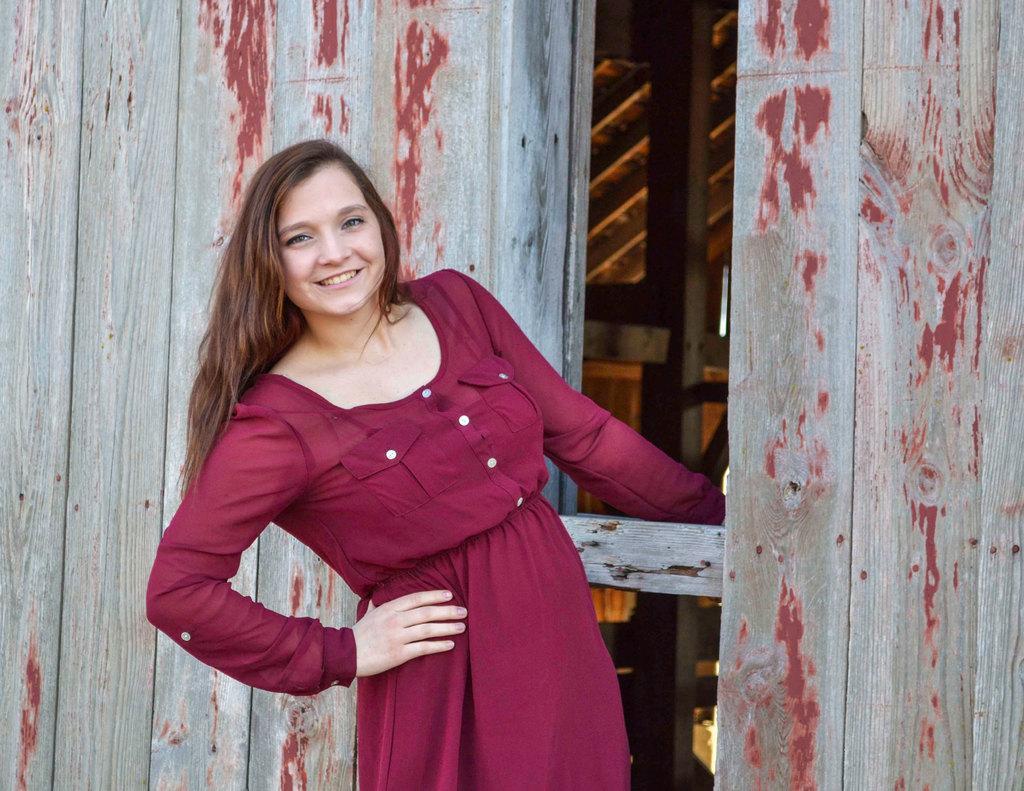In one or two sentences, can you explain what this image depicts? In this image we can see a girl holding a wooden stick of a wooden house. 